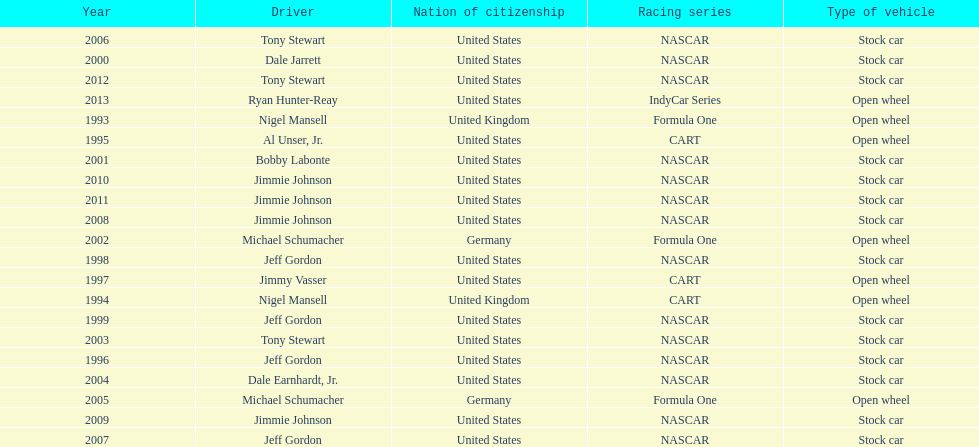Jimmy johnson won how many consecutive espy awards? 4. 